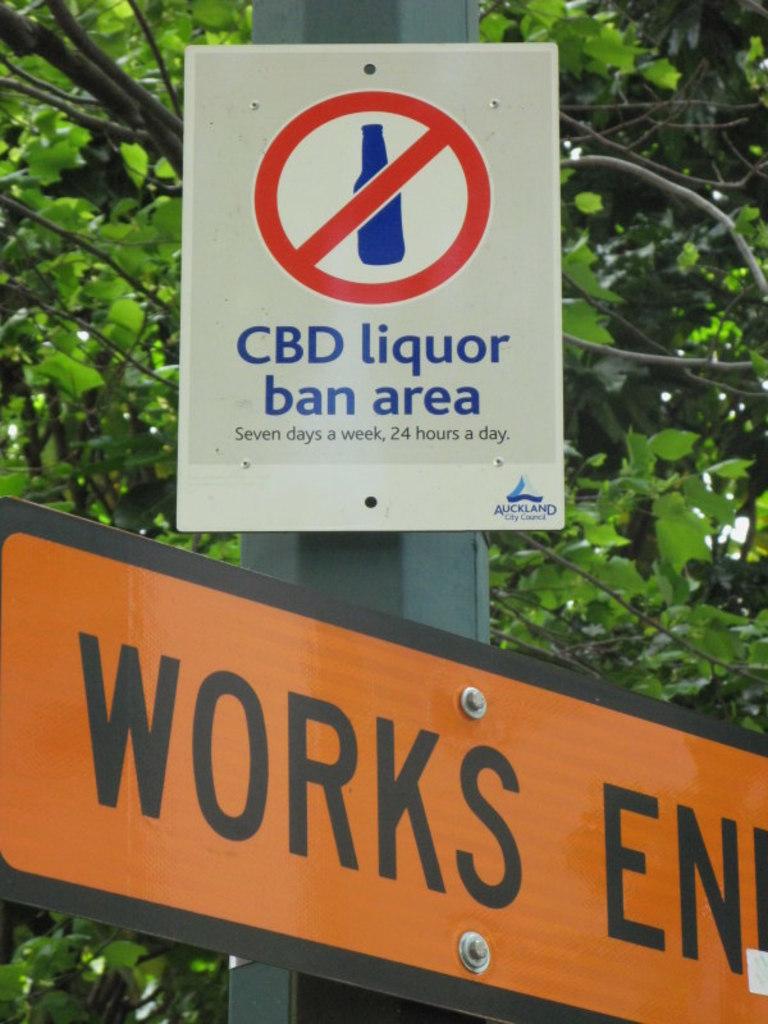What is the first word on the orange sign?
Your answer should be compact. Works. 